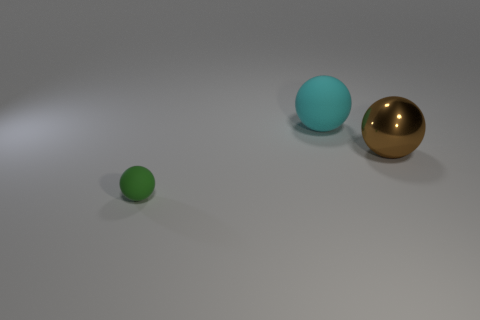Subtract all matte spheres. How many spheres are left? 1 Subtract all cyan balls. How many balls are left? 2 Add 2 gray blocks. How many objects exist? 5 Subtract 1 brown spheres. How many objects are left? 2 Subtract 2 spheres. How many spheres are left? 1 Subtract all gray balls. Subtract all green blocks. How many balls are left? 3 Subtract all red blocks. How many green balls are left? 1 Subtract all rubber balls. Subtract all big brown spheres. How many objects are left? 0 Add 1 big matte objects. How many big matte objects are left? 2 Add 1 big purple things. How many big purple things exist? 1 